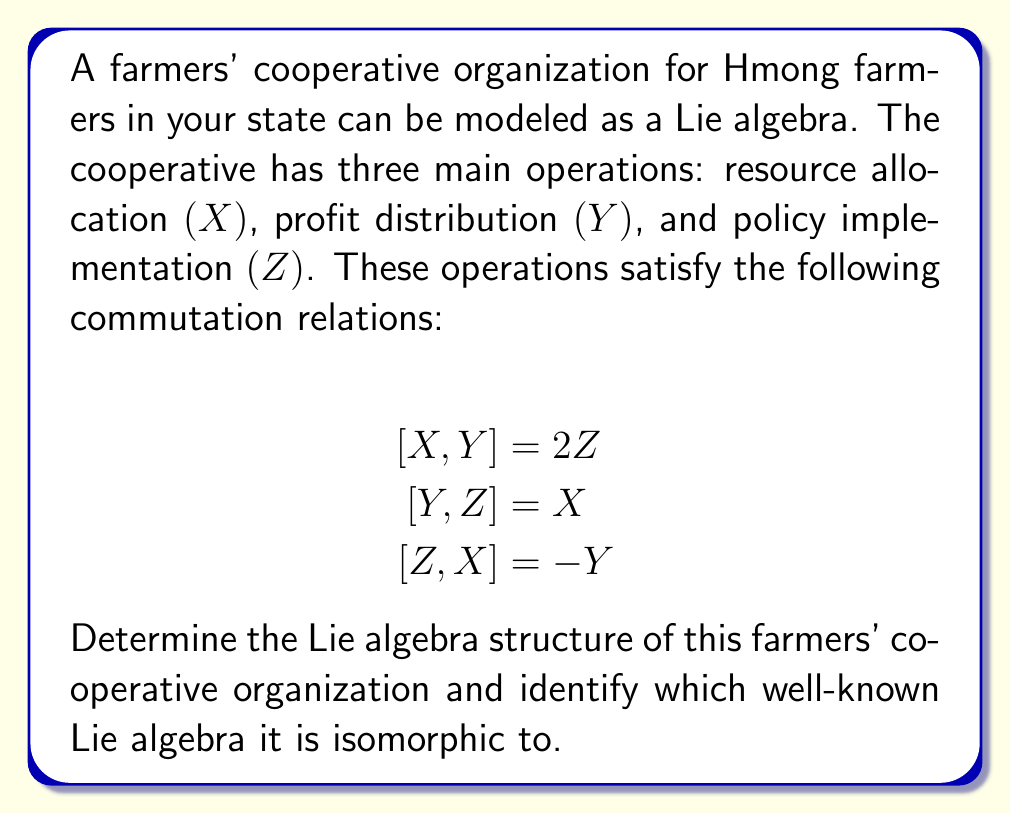Show me your answer to this math problem. To determine the Lie algebra structure, we need to analyze the given commutation relations and compare them to known Lie algebra structures.

1. First, let's observe the structure constants:
   $$[X,Y] = 2Z$$
   $$[Y,Z] = X$$
   $$[Z,X] = -Y$$

2. These relations are similar to the commutation relations of the special linear Lie algebra $\mathfrak{sl}(2,\mathbb{R})$, but with a slight modification.

3. To make the isomorphism clear, let's define new basis elements:
   $$E = \frac{1}{2}(X - iY)$$
   $$F = \frac{1}{2}(X + iY)$$
   $$H = iZ$$

4. Now, let's calculate the new commutation relations:

   $[E,F] = [\frac{1}{2}(X - iY), \frac{1}{2}(X + iY)]$
   $= \frac{1}{4}([X,X] + i[X,Y] - i[Y,X] - [Y,Y])$
   $= \frac{1}{4}(0 + 2iZ - (-2iZ) - 0) = iZ = H$

   $[H,E] = [iZ, \frac{1}{2}(X - iY)]$
   $= \frac{i}{2}([Z,X] - i[Z,Y]) = \frac{i}{2}(-Y - iX) = E$

   $[H,F] = [iZ, \frac{1}{2}(X + iY)]$
   $= \frac{i}{2}([Z,X] + i[Z,Y]) = \frac{i}{2}(-Y + iX) = -F$

5. These new commutation relations:
   $$[E,F] = H$$
   $$[H,E] = E$$
   $$[H,F] = -F$$

   are exactly the standard commutation relations for the Lie algebra $\mathfrak{sl}(2,\mathbb{C})$.

Therefore, the Lie algebra structure of the farmers' cooperative organization is isomorphic to $\mathfrak{sl}(2,\mathbb{C})$.
Answer: The Lie algebra structure of the farmers' cooperative organization is isomorphic to $\mathfrak{sl}(2,\mathbb{C})$, the special linear Lie algebra of $2 \times 2$ complex matrices with trace zero. 